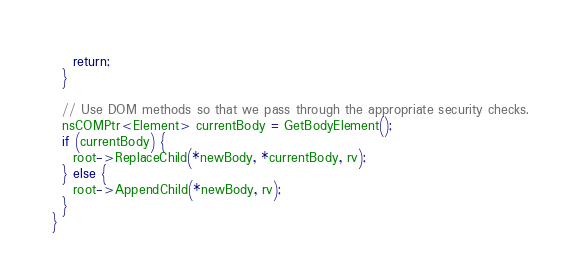<code> <loc_0><loc_0><loc_500><loc_500><_C_>    return;
  }

  // Use DOM methods so that we pass through the appropriate security checks.
  nsCOMPtr<Element> currentBody = GetBodyElement();
  if (currentBody) {
    root->ReplaceChild(*newBody, *currentBody, rv);
  } else {
    root->AppendChild(*newBody, rv);
  }
}
</code> 